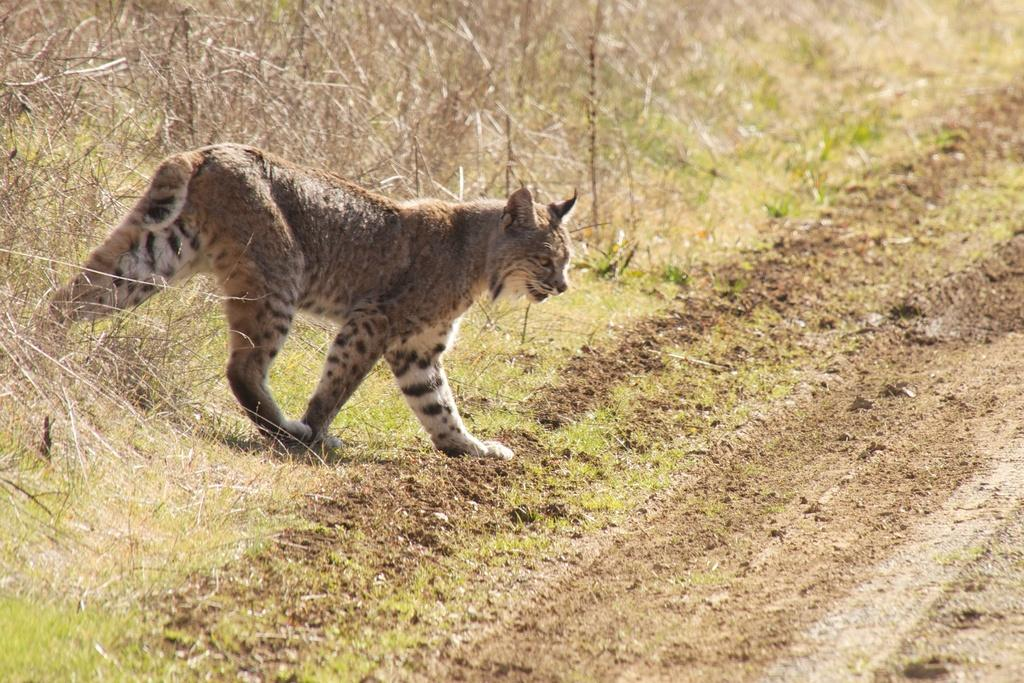What type of animal can be seen in the image? There is an animal in the image, but its specific type is not mentioned in the facts. What is the animal doing in the image? The animal is walking in the image. What type of vegetation is visible in the image? There is grass visible in the image. What can be seen in the background of the image? There are plants in the background of the image. What type of substance is the girl using to quilt in the image? There is no girl or quilt present in the image; it features an animal walking in a grassy area with plants in the background. 